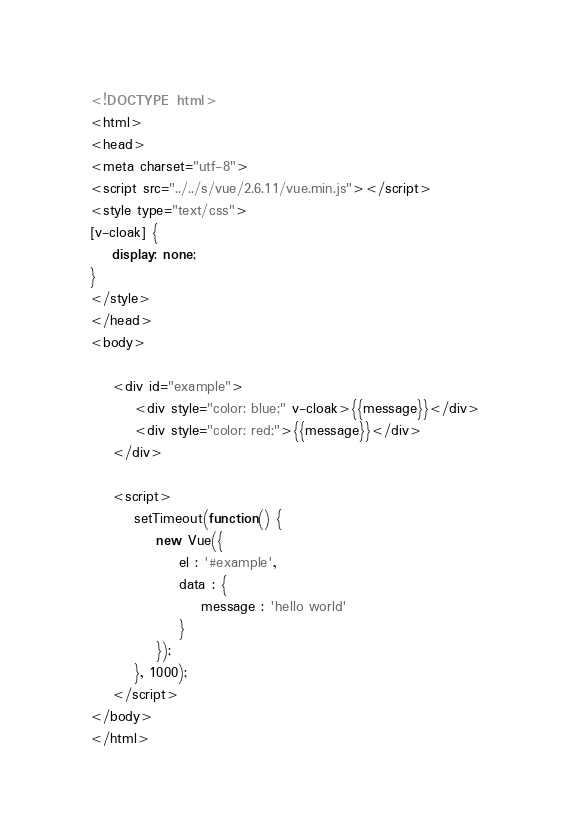Convert code to text. <code><loc_0><loc_0><loc_500><loc_500><_HTML_><!DOCTYPE html>
<html>
<head>
<meta charset="utf-8">
<script src="../../s/vue/2.6.11/vue.min.js"></script>
<style type="text/css">
[v-cloak] {
	display: none;
}
</style>
</head>
<body>

	<div id="example">
		<div style="color: blue;" v-cloak>{{message}}</div>
		<div style="color: red;">{{message}}</div>
	</div>

	<script>
		setTimeout(function() {
			new Vue({
				el : '#example',
				data : {
					message : 'hello world'
				}
			});
		}, 1000);
	</script>
</body>
</html></code> 